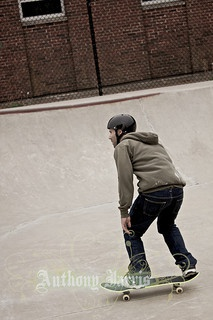Describe the objects in this image and their specific colors. I can see people in black, gray, and darkgray tones and skateboard in black, gray, and darkgray tones in this image. 